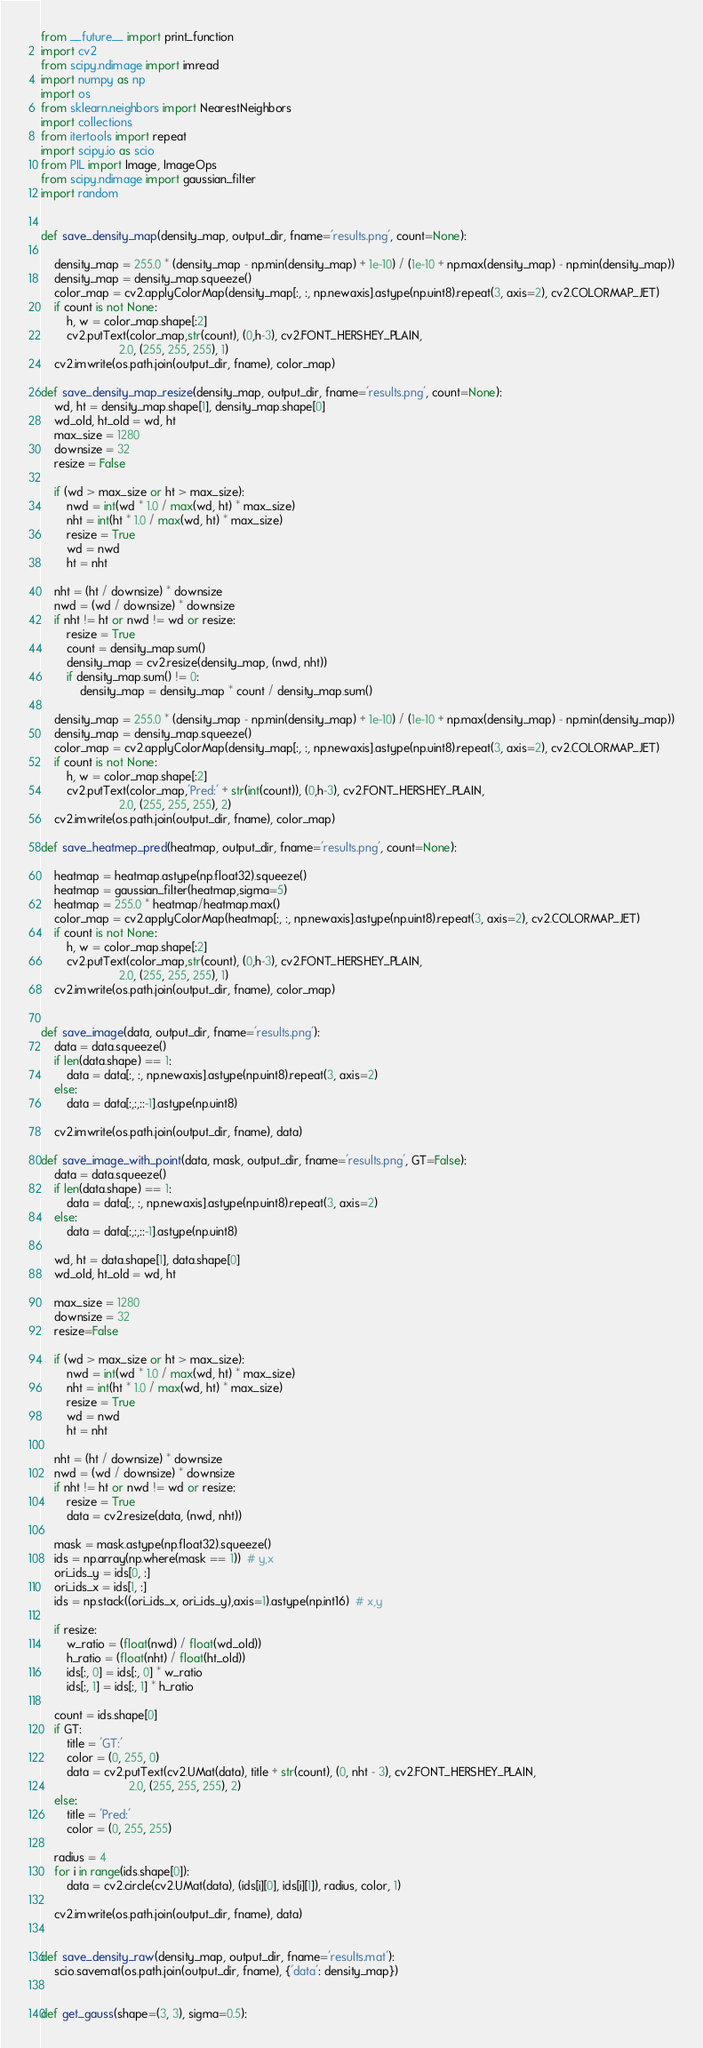<code> <loc_0><loc_0><loc_500><loc_500><_Python_>from __future__ import print_function
import cv2
from scipy.ndimage import imread
import numpy as np
import os
from sklearn.neighbors import NearestNeighbors
import collections
from itertools import repeat
import scipy.io as scio
from PIL import Image, ImageOps
from scipy.ndimage import gaussian_filter
import random


def save_density_map(density_map, output_dir, fname='results.png', count=None):

    density_map = 255.0 * (density_map - np.min(density_map) + 1e-10) / (1e-10 + np.max(density_map) - np.min(density_map))
    density_map = density_map.squeeze()
    color_map = cv2.applyColorMap(density_map[:, :, np.newaxis].astype(np.uint8).repeat(3, axis=2), cv2.COLORMAP_JET)
    if count is not None:
        h, w = color_map.shape[:2]
        cv2.putText(color_map,str(count), (0,h-3), cv2.FONT_HERSHEY_PLAIN,
                        2.0, (255, 255, 255), 1)
    cv2.imwrite(os.path.join(output_dir, fname), color_map)

def save_density_map_resize(density_map, output_dir, fname='results.png', count=None):
    wd, ht = density_map.shape[1], density_map.shape[0]
    wd_old, ht_old = wd, ht
    max_size = 1280
    downsize = 32
    resize = False

    if (wd > max_size or ht > max_size):
        nwd = int(wd * 1.0 / max(wd, ht) * max_size)
        nht = int(ht * 1.0 / max(wd, ht) * max_size)
        resize = True
        wd = nwd
        ht = nht

    nht = (ht / downsize) * downsize
    nwd = (wd / downsize) * downsize
    if nht != ht or nwd != wd or resize:
        resize = True
        count = density_map.sum()
        density_map = cv2.resize(density_map, (nwd, nht))
        if density_map.sum() != 0:
            density_map = density_map * count / density_map.sum()

    density_map = 255.0 * (density_map - np.min(density_map) + 1e-10) / (1e-10 + np.max(density_map) - np.min(density_map))
    density_map = density_map.squeeze()
    color_map = cv2.applyColorMap(density_map[:, :, np.newaxis].astype(np.uint8).repeat(3, axis=2), cv2.COLORMAP_JET)
    if count is not None:
        h, w = color_map.shape[:2]
        cv2.putText(color_map,'Pred:' + str(int(count)), (0,h-3), cv2.FONT_HERSHEY_PLAIN,
                        2.0, (255, 255, 255), 2)
    cv2.imwrite(os.path.join(output_dir, fname), color_map)

def save_heatmep_pred(heatmap, output_dir, fname='results.png', count=None):

    heatmap = heatmap.astype(np.float32).squeeze()
    heatmap = gaussian_filter(heatmap,sigma=5)
    heatmap = 255.0 * heatmap/heatmap.max()
    color_map = cv2.applyColorMap(heatmap[:, :, np.newaxis].astype(np.uint8).repeat(3, axis=2), cv2.COLORMAP_JET)
    if count is not None:
        h, w = color_map.shape[:2]
        cv2.putText(color_map,str(count), (0,h-3), cv2.FONT_HERSHEY_PLAIN,
                        2.0, (255, 255, 255), 1)
    cv2.imwrite(os.path.join(output_dir, fname), color_map)


def save_image(data, output_dir, fname='results.png'):
    data = data.squeeze()
    if len(data.shape) == 1:
        data = data[:, :, np.newaxis].astype(np.uint8).repeat(3, axis=2)
    else:
        data = data[:,:,::-1].astype(np.uint8)

    cv2.imwrite(os.path.join(output_dir, fname), data)

def save_image_with_point(data, mask, output_dir, fname='results.png', GT=False):
    data = data.squeeze()
    if len(data.shape) == 1:
        data = data[:, :, np.newaxis].astype(np.uint8).repeat(3, axis=2)
    else:
        data = data[:,:,::-1].astype(np.uint8)

    wd, ht = data.shape[1], data.shape[0]
    wd_old, ht_old = wd, ht

    max_size = 1280
    downsize = 32
    resize=False

    if (wd > max_size or ht > max_size):
        nwd = int(wd * 1.0 / max(wd, ht) * max_size)
        nht = int(ht * 1.0 / max(wd, ht) * max_size)
        resize = True
        wd = nwd
        ht = nht

    nht = (ht / downsize) * downsize
    nwd = (wd / downsize) * downsize
    if nht != ht or nwd != wd or resize:
        resize = True
        data = cv2.resize(data, (nwd, nht))

    mask = mask.astype(np.float32).squeeze()
    ids = np.array(np.where(mask == 1))  # y,x
    ori_ids_y = ids[0, :]
    ori_ids_x = ids[1, :]
    ids = np.stack((ori_ids_x, ori_ids_y),axis=1).astype(np.int16)  # x,y

    if resize:
        w_ratio = (float(nwd) / float(wd_old))
        h_ratio = (float(nht) / float(ht_old))
        ids[:, 0] = ids[:, 0] * w_ratio
        ids[:, 1] = ids[:, 1] * h_ratio

    count = ids.shape[0]
    if GT:
        title = 'GT:'
        color = (0, 255, 0)
        data = cv2.putText(cv2.UMat(data), title + str(count), (0, nht - 3), cv2.FONT_HERSHEY_PLAIN,
                           2.0, (255, 255, 255), 2)
    else:
        title = 'Pred:'
        color = (0, 255, 255)

    radius = 4
    for i in range(ids.shape[0]):
        data = cv2.circle(cv2.UMat(data), (ids[i][0], ids[i][1]), radius, color, 1)

    cv2.imwrite(os.path.join(output_dir, fname), data)


def save_density_raw(density_map, output_dir, fname='results.mat'):
    scio.savemat(os.path.join(output_dir, fname), {'data': density_map})


def get_gauss(shape=(3, 3), sigma=0.5):</code> 